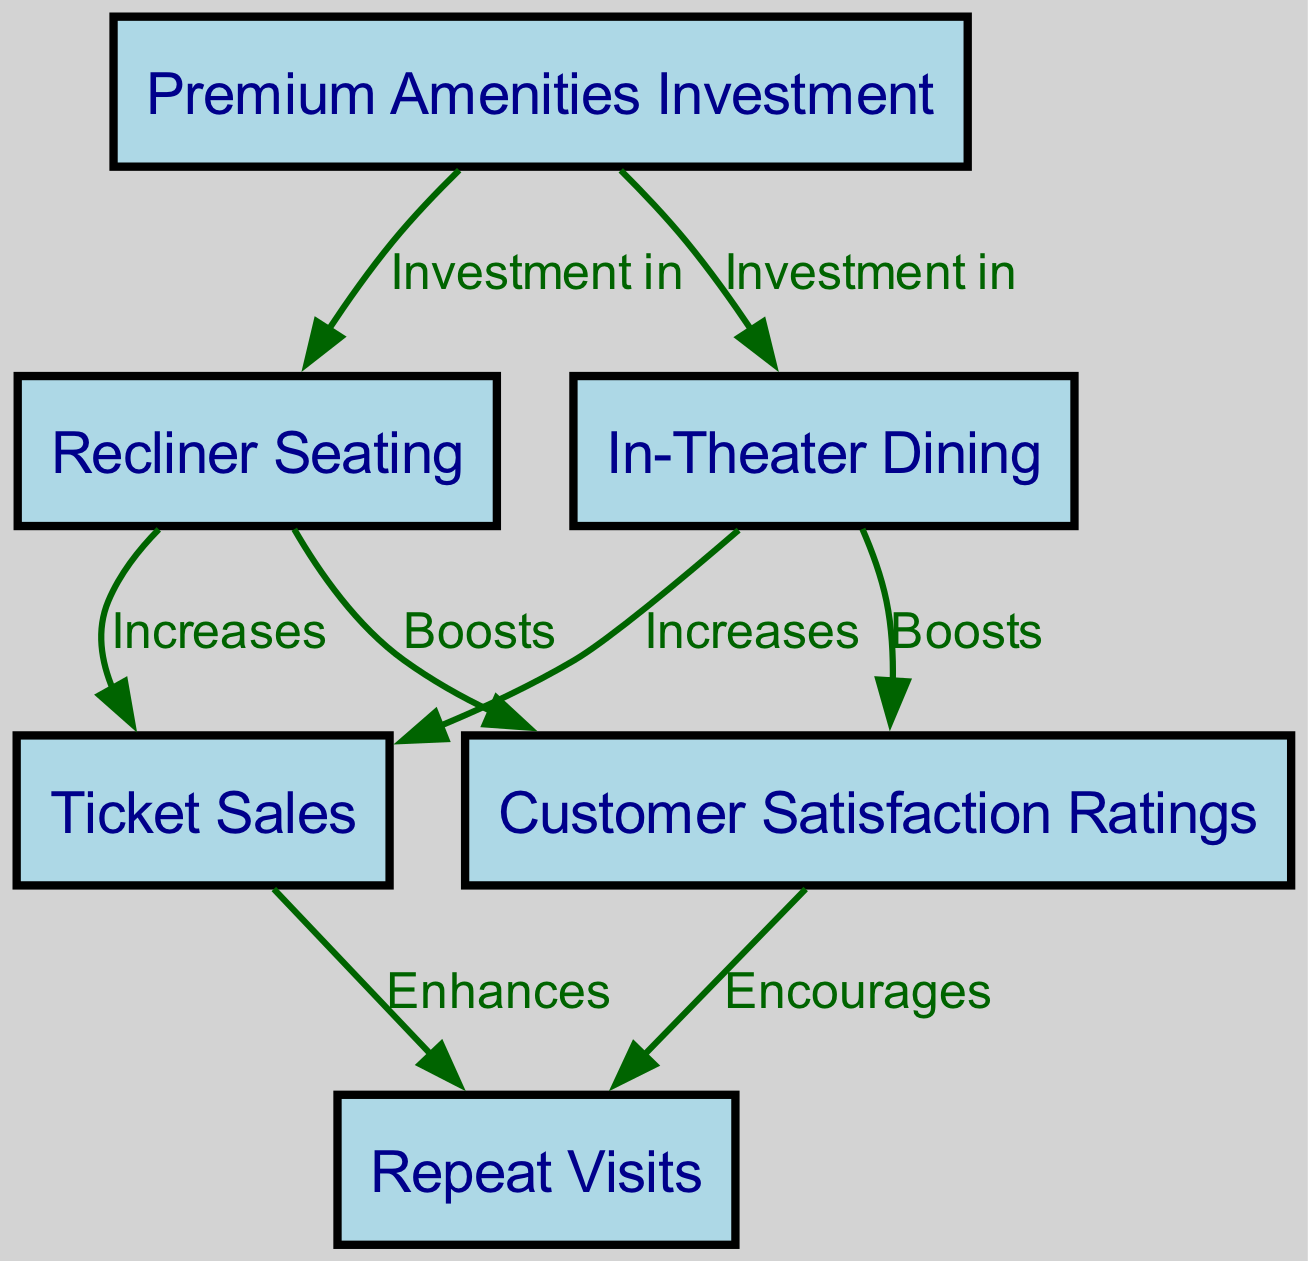What nodes are present in the diagram? The diagram includes six nodes: Premium Amenities Investment, Recliner Seating, In-Theater Dining, Ticket Sales, Customer Satisfaction Ratings, and Repeat Visits.
Answer: Premium Amenities Investment, Recliner Seating, In-Theater Dining, Ticket Sales, Customer Satisfaction Ratings, Repeat Visits How many edges are there connecting the nodes? There are eight edges in the diagram, each representing the relationship between nodes concerning amenities investment and their impact on various metrics.
Answer: Eight Which node is directly influenced by In-Theater Dining? In-Theater Dining has direct edges leading to Ticket Sales and Customer Satisfaction, meaning both these nodes are influenced by it.
Answer: Ticket Sales, Customer Satisfaction What is the relationship between Recliner Seating and Ticket Sales? Recliner Seating directly increases Ticket Sales, as indicated by the edge labeled "Increases" from Recliner Seating to Ticket Sales.
Answer: Increases What does Customer Satisfaction encourage? Customer Satisfaction directly encourages Repeat Visits as represented by the edge labeled "Encourages" flowing from Customer Satisfaction to Repeat Visits.
Answer: Repeat Visits If an increase in Premium Amenities Investment occurs, which two metrics will likely improve? An increase in Premium Amenities Investment will likely improve both Ticket Sales and Customer Satisfaction as indicated by the direct edges leading from Premium Amenities to these two metrics.
Answer: Ticket Sales, Customer Satisfaction How does the investment in Premium Amenities affect Recliner Seating? Investment in Premium Amenities directly leads to the addition of Recliner Seating, as shown by the edge from Premium Amenities to Recliner Seating, labeled "Investment in."
Answer: Investment in Which node boosts Customer Satisfaction? Both Recliner Seating and In-Theater Dining boost Customer Satisfaction as indicated by the edges labeled "Boosts" from these nodes to Customer Satisfaction.
Answer: Recliner Seating, In-Theater Dining Which metrics are enhanced by Ticket Sales? Ticket Sales enhances Repeat Visits, as indicated by the edge from Ticket Sales to Repeat Visits, labeled "Enhances."
Answer: Repeat Visits 